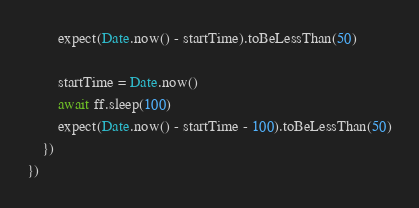Convert code to text. <code><loc_0><loc_0><loc_500><loc_500><_TypeScript_>		expect(Date.now() - startTime).toBeLessThan(50)

		startTime = Date.now()
		await ff.sleep(100)
		expect(Date.now() - startTime - 100).toBeLessThan(50)
	})
})</code> 